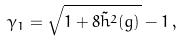Convert formula to latex. <formula><loc_0><loc_0><loc_500><loc_500>\gamma _ { 1 } = \sqrt { 1 + 8 \tilde { h } ^ { 2 } ( g ) } - 1 \, ,</formula> 